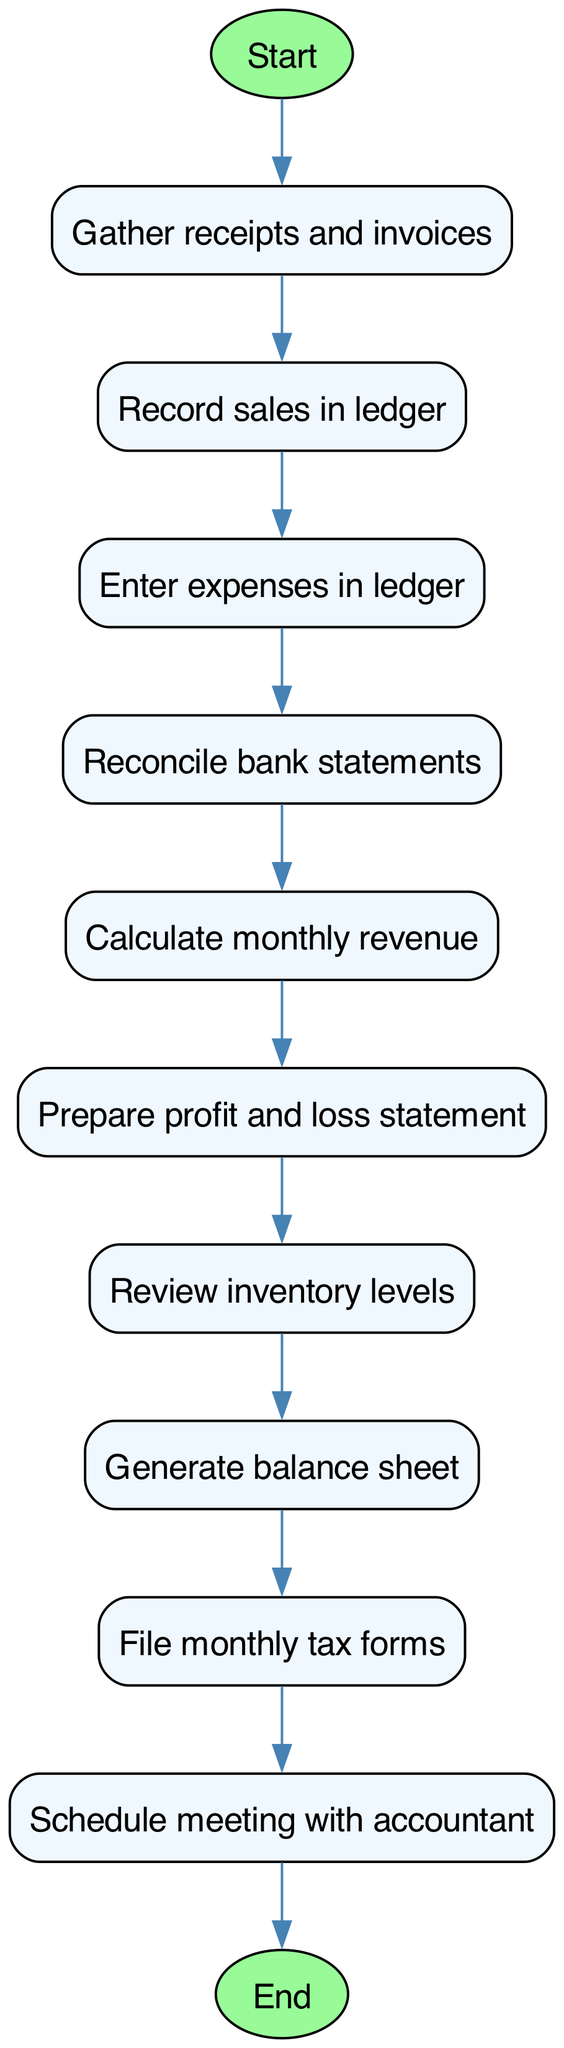What is the first step in the process? The first step, indicated by the starting node, is "Gather receipts and invoices." This is the initial action that kicks off the entire bookkeeping procedure.
Answer: Gather receipts and invoices How many nodes are in the diagram? To find the number of nodes, we count all individual steps listed in the nodes array. There are eleven different nodes in total.
Answer: Eleven What comes after "Prepare profit and loss statement"? Following the "Prepare profit and loss statement" node, the next step is "Review inventory levels." This shows the sequential flow of actions in the diagram.
Answer: Review inventory levels How many edges are present in the diagram? Each edge represents a transition from one node to another. Counting the connections in the edges array shows there are ten edges in total.
Answer: Ten Which node directly follows "File monthly tax forms"? The node that comes directly after "File monthly tax forms" is "Schedule meeting with accountant." This indicates what will happen next in the procedure.
Answer: Schedule meeting with accountant What is the last step in the process? The last step, indicated by the end node, is "End." This signifies that the bookkeeping process is complete after all prior activities have been performed.
Answer: End What is the relationship between "Reconcile bank statements" and "Calculate monthly revenue"? "Reconcile bank statements" leads directly to "Calculate monthly revenue," indicating that reconciling the bank statements is a prerequisite for determining the monthly revenue.
Answer: Direct relationship How many steps must be completed before filing monthly tax forms? There are eight steps that must be completed before reaching "File monthly tax forms," as the diagram shows the sequence of actions leading to this node.
Answer: Eight steps What action follows "Generate balance sheet"? The action that follows "Generate balance sheet" is "File monthly tax forms." This indicates the order in which these actions take place.
Answer: File monthly tax forms 